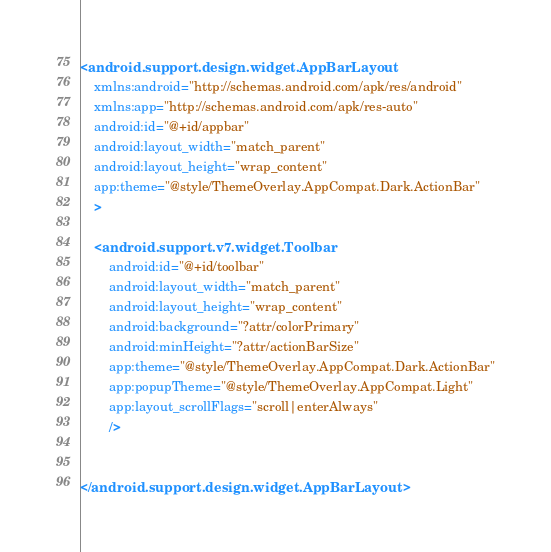Convert code to text. <code><loc_0><loc_0><loc_500><loc_500><_XML_><android.support.design.widget.AppBarLayout
	xmlns:android="http://schemas.android.com/apk/res/android"
	xmlns:app="http://schemas.android.com/apk/res-auto"
	android:id="@+id/appbar"
	android:layout_width="match_parent"
	android:layout_height="wrap_content"
	app:theme="@style/ThemeOverlay.AppCompat.Dark.ActionBar"
	>

	<android.support.v7.widget.Toolbar
		android:id="@+id/toolbar"
		android:layout_width="match_parent"
		android:layout_height="wrap_content"
		android:background="?attr/colorPrimary"
		android:minHeight="?attr/actionBarSize"
		app:theme="@style/ThemeOverlay.AppCompat.Dark.ActionBar"
		app:popupTheme="@style/ThemeOverlay.AppCompat.Light"
		app:layout_scrollFlags="scroll|enterAlways"
		/>


</android.support.design.widget.AppBarLayout>
</code> 